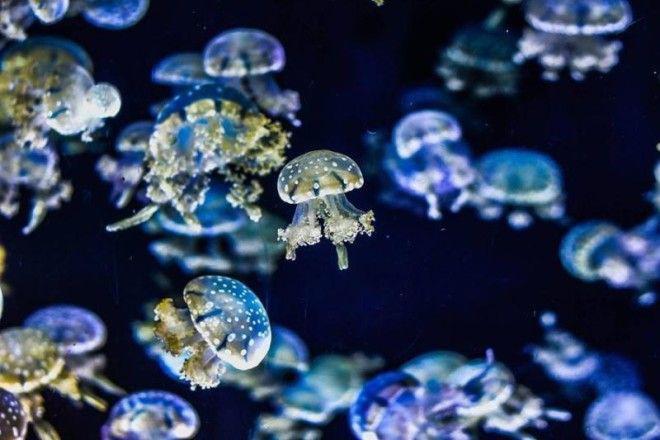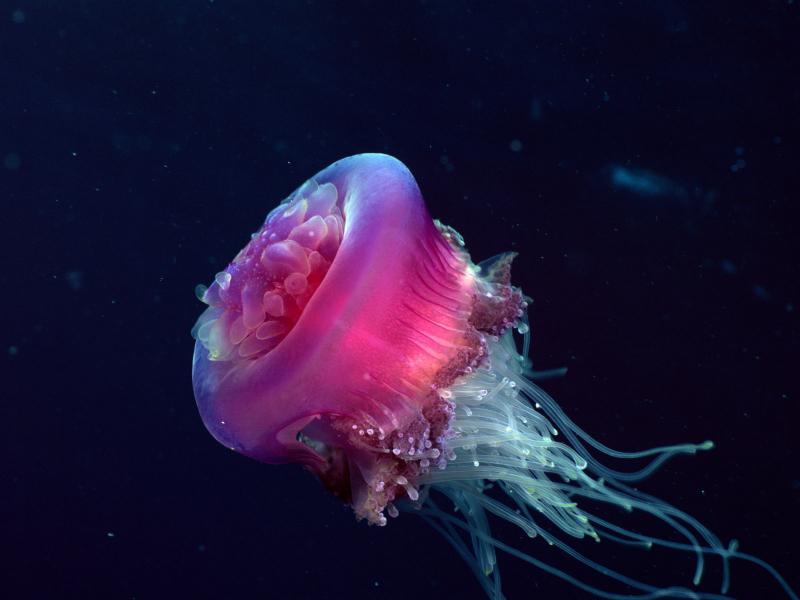The first image is the image on the left, the second image is the image on the right. Evaluate the accuracy of this statement regarding the images: "An image shows at least a dozen vivid orange jellyfish, with tendrils trailing upward.". Is it true? Answer yes or no. No. The first image is the image on the left, the second image is the image on the right. For the images shown, is this caption "Gold colored jellyfish are swimming down." true? Answer yes or no. No. 